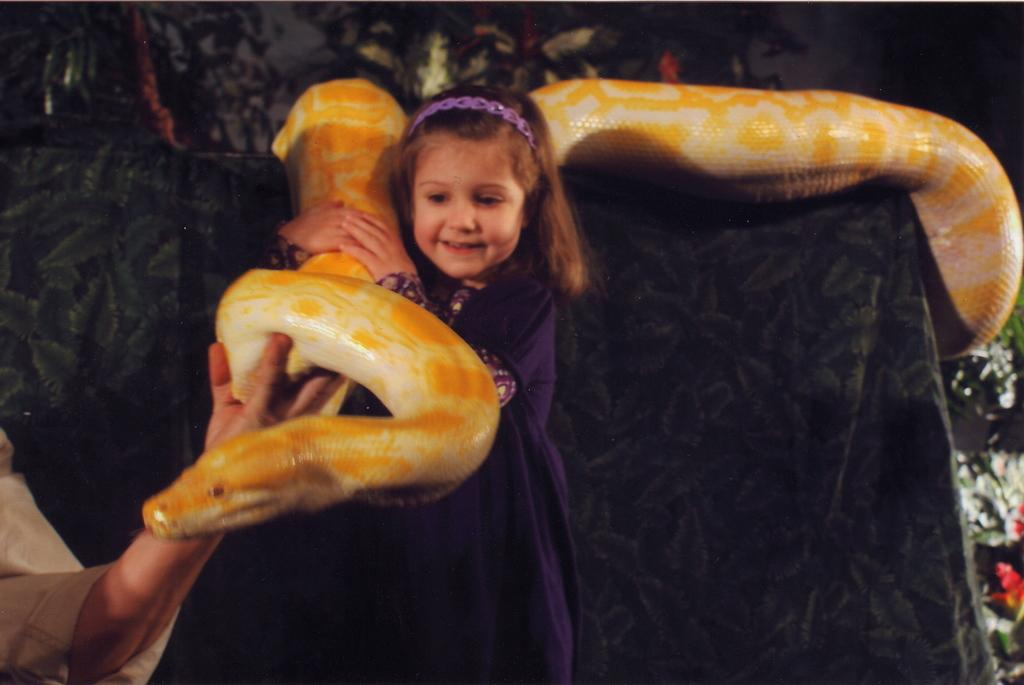Who is present in the image? There is a girl in the image. What is the girl holding in the image? The girl is holding a snake. Is there anyone else interacting with the snake in the image? Yes, there is a person's hand on the snake. What can be seen in the background of the image? There is cloth visible in the background of the image. What type of battle is taking place in the image? There is no battle present in the image; it features a girl holding a snake. Can you hear thunder in the image? There is no sound present in the image, so it is not possible to determine if thunder can be heard. 